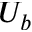Convert formula to latex. <formula><loc_0><loc_0><loc_500><loc_500>U _ { b }</formula> 